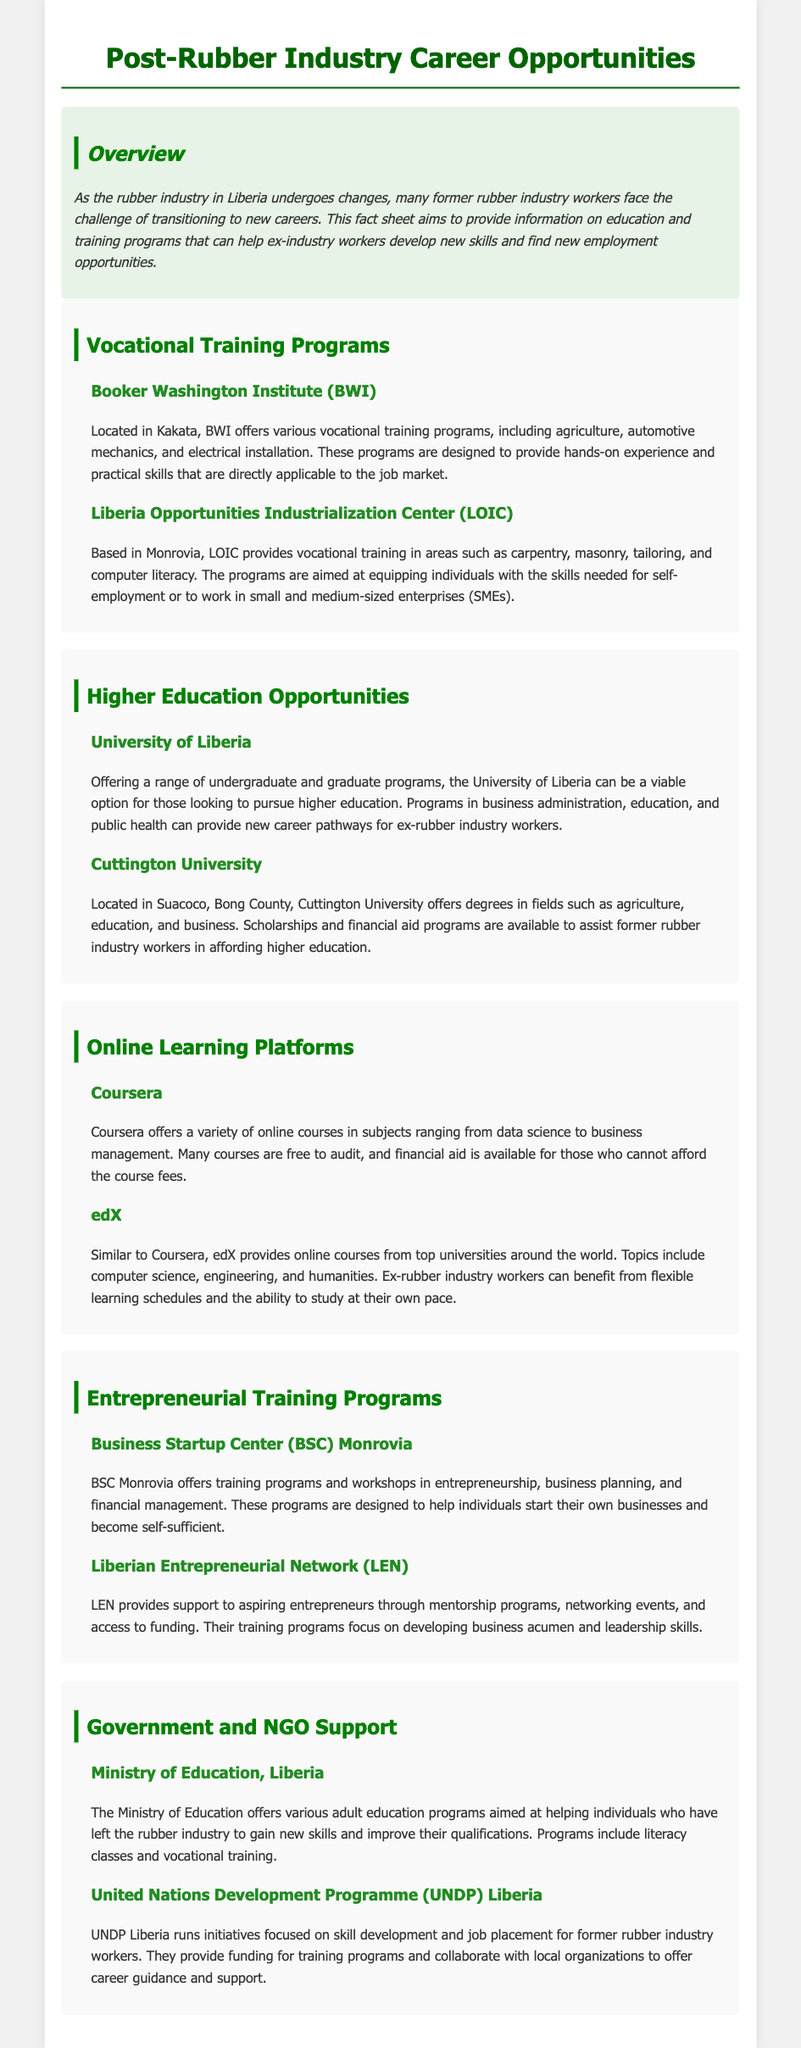what programs does Booker Washington Institute offer? Booker Washington Institute offers vocational training programs, including agriculture, automotive mechanics, and electrical installation.
Answer: agriculture, automotive mechanics, electrical installation where is Liberia Opportunities Industrialization Center based? Liberia Opportunities Industrialization Center is located in Monrovia.
Answer: Monrovia what is a higher education option offered at the University of Liberia? The University of Liberia offers programs in business administration, education, and public health.
Answer: business administration what type of courses does edX provide? edX provides online courses from top universities in subjects like computer science, engineering, and humanities.
Answer: computer science, engineering, humanities which organization provides training workshops in entrepreneurship in Monrovia? The Business Startup Center (BSC) Monrovia offers training programs and workshops in entrepreneurship.
Answer: Business Startup Center (BSC) Monrovia what type of support does UNDP Liberia offer for former rubber industry workers? UNDP Liberia runs initiatives focused on skill development and job placement for former rubber industry workers.
Answer: skill development and job placement what is the goal of the training programs at the Liberian Entrepreneurial Network? The goal of LEN's training programs is to develop business acumen and leadership skills.
Answer: business acumen and leadership skills how does the Minister of Education support former rubber industry workers? The Ministry of Education offers various adult education programs, including literacy classes and vocational training.
Answer: literacy classes and vocational training 